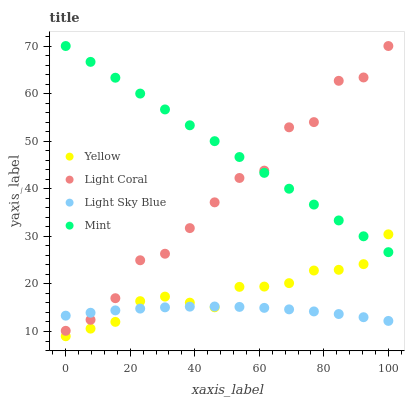Does Light Sky Blue have the minimum area under the curve?
Answer yes or no. Yes. Does Mint have the maximum area under the curve?
Answer yes or no. Yes. Does Mint have the minimum area under the curve?
Answer yes or no. No. Does Light Sky Blue have the maximum area under the curve?
Answer yes or no. No. Is Mint the smoothest?
Answer yes or no. Yes. Is Light Coral the roughest?
Answer yes or no. Yes. Is Light Sky Blue the smoothest?
Answer yes or no. No. Is Light Sky Blue the roughest?
Answer yes or no. No. Does Yellow have the lowest value?
Answer yes or no. Yes. Does Light Sky Blue have the lowest value?
Answer yes or no. No. Does Mint have the highest value?
Answer yes or no. Yes. Does Light Sky Blue have the highest value?
Answer yes or no. No. Is Yellow less than Light Coral?
Answer yes or no. Yes. Is Light Coral greater than Yellow?
Answer yes or no. Yes. Does Mint intersect Light Coral?
Answer yes or no. Yes. Is Mint less than Light Coral?
Answer yes or no. No. Is Mint greater than Light Coral?
Answer yes or no. No. Does Yellow intersect Light Coral?
Answer yes or no. No. 